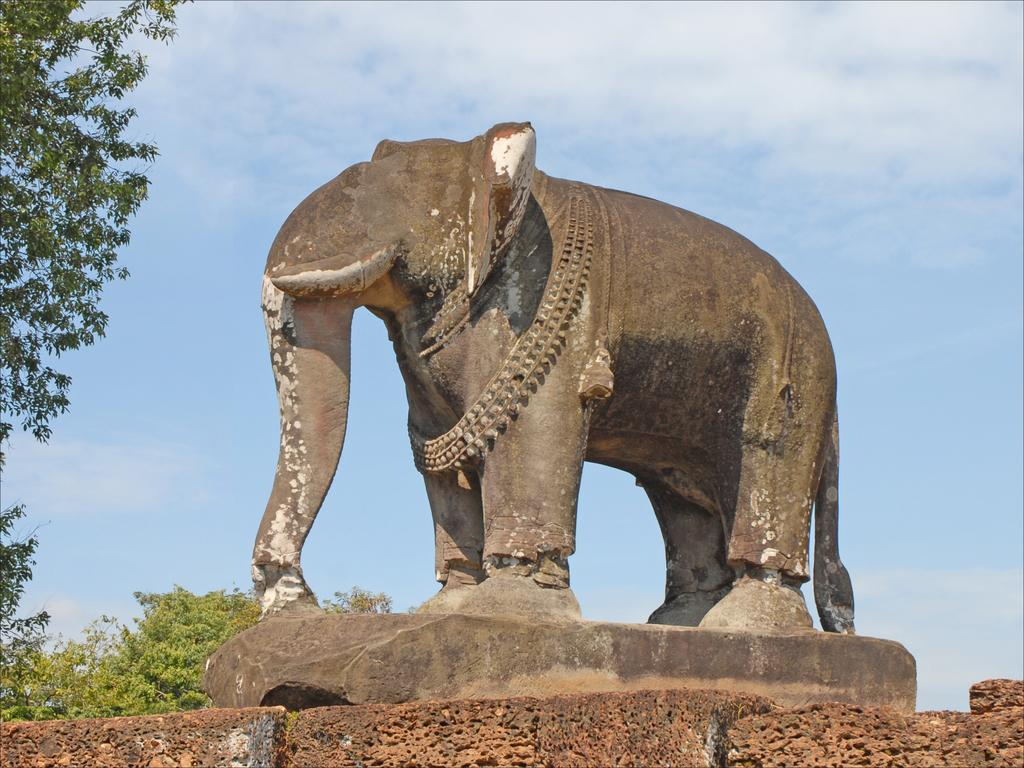What is the main subject of the image? There is a statue of an elephant in the image. What can be seen on the left side of the image? There are trees on the left side of the image. What is visible in the background of the image? There are trees and the sky visible in the background of the image. What type of net can be seen hanging from the elephant's trunk in the image? There is no net present in the image, and the elephant's trunk does not have any hanging objects. 